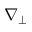Convert formula to latex. <formula><loc_0><loc_0><loc_500><loc_500>\nabla _ { \perp }</formula> 